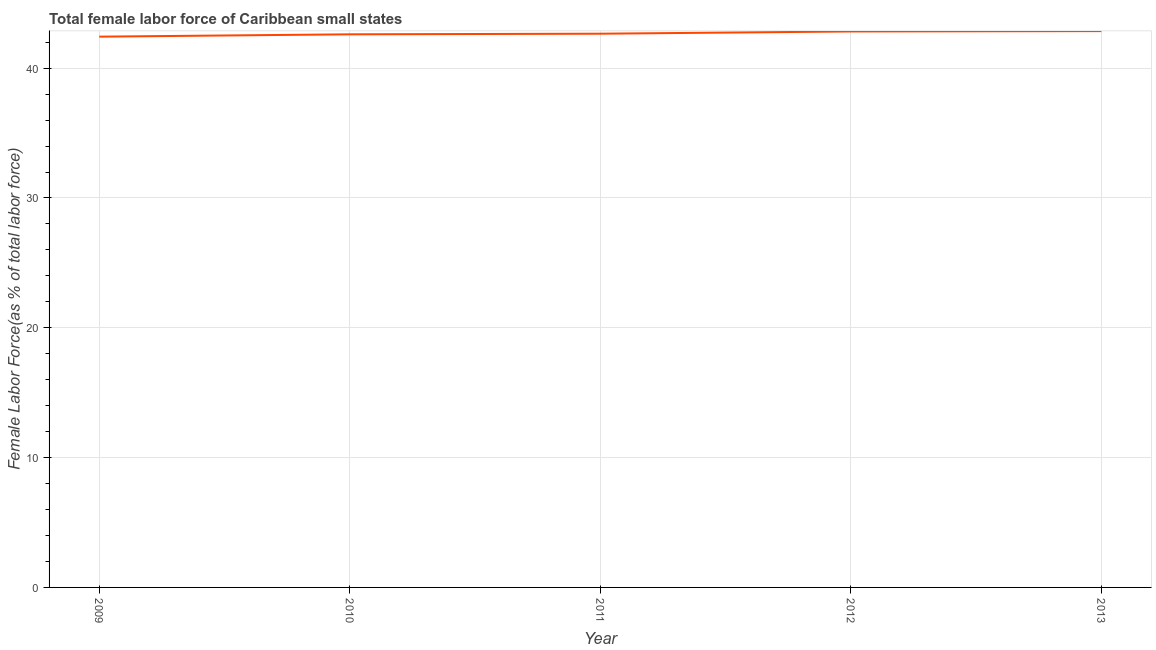What is the total female labor force in 2011?
Provide a short and direct response. 42.66. Across all years, what is the maximum total female labor force?
Your response must be concise. 42.86. Across all years, what is the minimum total female labor force?
Give a very brief answer. 42.43. What is the sum of the total female labor force?
Make the answer very short. 213.37. What is the difference between the total female labor force in 2009 and 2013?
Keep it short and to the point. -0.43. What is the average total female labor force per year?
Offer a terse response. 42.67. What is the median total female labor force?
Your response must be concise. 42.66. In how many years, is the total female labor force greater than 16 %?
Your response must be concise. 5. Do a majority of the years between 2009 and 2010 (inclusive) have total female labor force greater than 12 %?
Your answer should be very brief. Yes. What is the ratio of the total female labor force in 2011 to that in 2013?
Ensure brevity in your answer.  1. Is the difference between the total female labor force in 2012 and 2013 greater than the difference between any two years?
Provide a short and direct response. No. What is the difference between the highest and the second highest total female labor force?
Offer a terse response. 0.03. Is the sum of the total female labor force in 2012 and 2013 greater than the maximum total female labor force across all years?
Offer a very short reply. Yes. What is the difference between the highest and the lowest total female labor force?
Your answer should be very brief. 0.43. Are the values on the major ticks of Y-axis written in scientific E-notation?
Give a very brief answer. No. What is the title of the graph?
Offer a very short reply. Total female labor force of Caribbean small states. What is the label or title of the X-axis?
Give a very brief answer. Year. What is the label or title of the Y-axis?
Offer a very short reply. Female Labor Force(as % of total labor force). What is the Female Labor Force(as % of total labor force) in 2009?
Offer a terse response. 42.43. What is the Female Labor Force(as % of total labor force) in 2010?
Ensure brevity in your answer.  42.61. What is the Female Labor Force(as % of total labor force) in 2011?
Make the answer very short. 42.66. What is the Female Labor Force(as % of total labor force) of 2012?
Offer a terse response. 42.83. What is the Female Labor Force(as % of total labor force) in 2013?
Ensure brevity in your answer.  42.86. What is the difference between the Female Labor Force(as % of total labor force) in 2009 and 2010?
Your answer should be compact. -0.18. What is the difference between the Female Labor Force(as % of total labor force) in 2009 and 2011?
Keep it short and to the point. -0.23. What is the difference between the Female Labor Force(as % of total labor force) in 2009 and 2012?
Your answer should be compact. -0.4. What is the difference between the Female Labor Force(as % of total labor force) in 2009 and 2013?
Provide a short and direct response. -0.43. What is the difference between the Female Labor Force(as % of total labor force) in 2010 and 2011?
Offer a terse response. -0.05. What is the difference between the Female Labor Force(as % of total labor force) in 2010 and 2012?
Give a very brief answer. -0.22. What is the difference between the Female Labor Force(as % of total labor force) in 2010 and 2013?
Ensure brevity in your answer.  -0.25. What is the difference between the Female Labor Force(as % of total labor force) in 2011 and 2012?
Your answer should be very brief. -0.17. What is the difference between the Female Labor Force(as % of total labor force) in 2011 and 2013?
Ensure brevity in your answer.  -0.2. What is the difference between the Female Labor Force(as % of total labor force) in 2012 and 2013?
Provide a short and direct response. -0.03. What is the ratio of the Female Labor Force(as % of total labor force) in 2009 to that in 2010?
Make the answer very short. 1. What is the ratio of the Female Labor Force(as % of total labor force) in 2009 to that in 2011?
Provide a succinct answer. 0.99. What is the ratio of the Female Labor Force(as % of total labor force) in 2009 to that in 2013?
Your answer should be very brief. 0.99. What is the ratio of the Female Labor Force(as % of total labor force) in 2011 to that in 2012?
Keep it short and to the point. 1. What is the ratio of the Female Labor Force(as % of total labor force) in 2011 to that in 2013?
Ensure brevity in your answer.  0.99. What is the ratio of the Female Labor Force(as % of total labor force) in 2012 to that in 2013?
Provide a succinct answer. 1. 